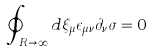<formula> <loc_0><loc_0><loc_500><loc_500>\oint _ { R \to \infty } d \xi _ { \mu } \epsilon _ { \mu \nu } \partial _ { \nu } \sigma = 0</formula> 